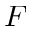<formula> <loc_0><loc_0><loc_500><loc_500>F</formula> 